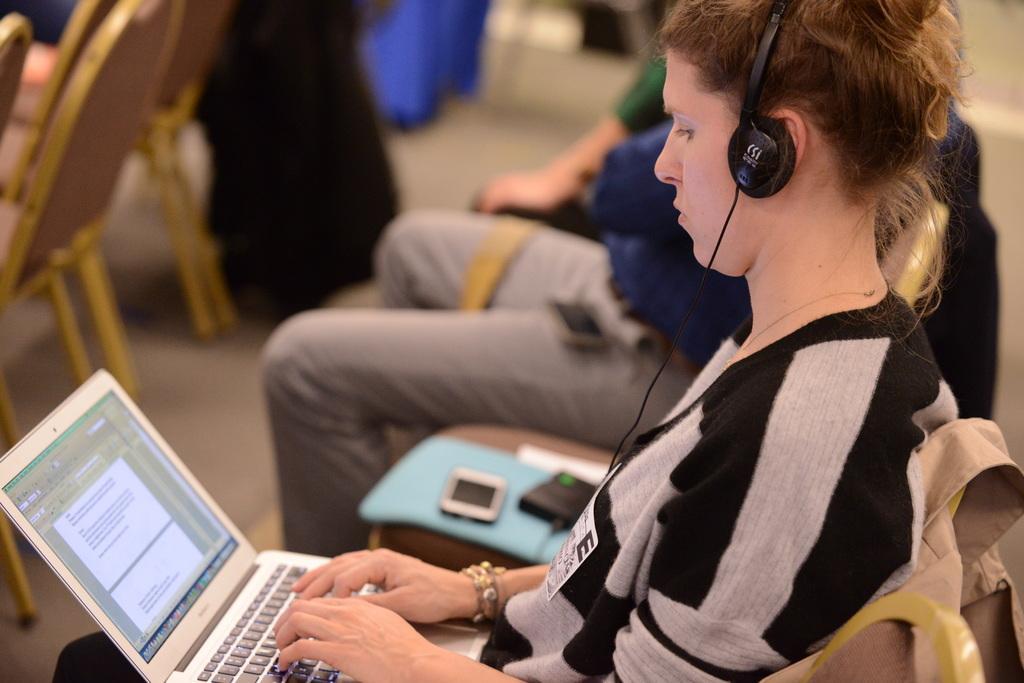Please provide a concise description of this image. In the picture I can see people are sitting on chairs, among them the woman in the front is sitting and using a laptop. The woman is also wearing headphones. The background of the image is blurred. 